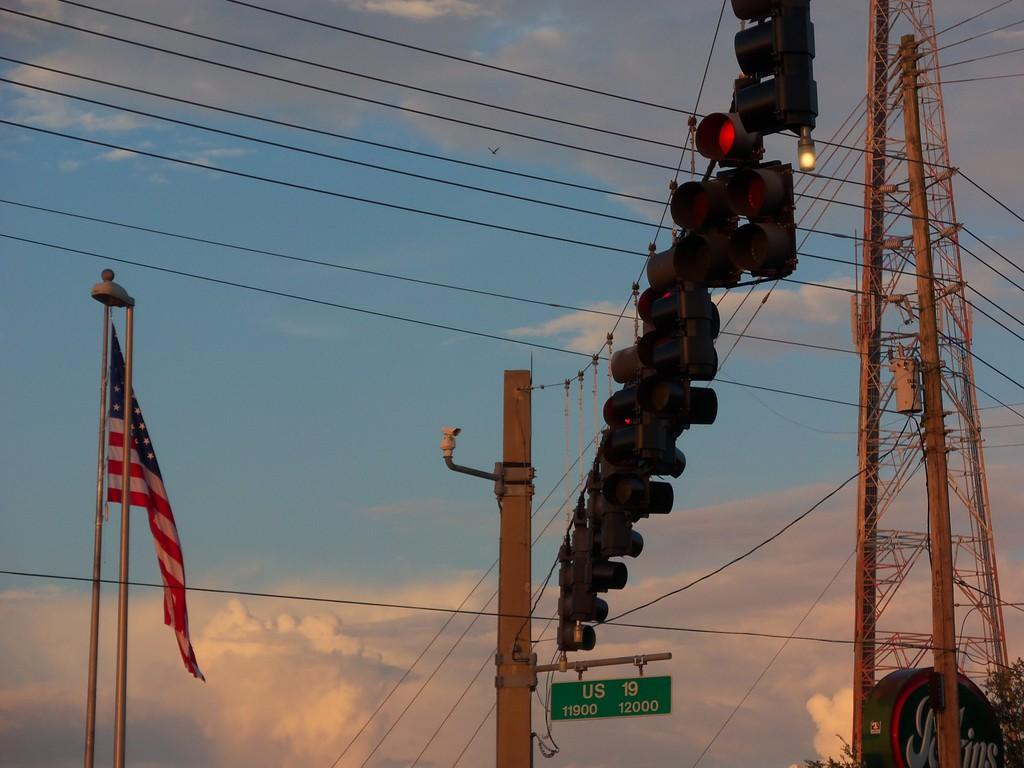<image>
Write a terse but informative summary of the picture. The sign reads US 19 which is the street below the lights. 